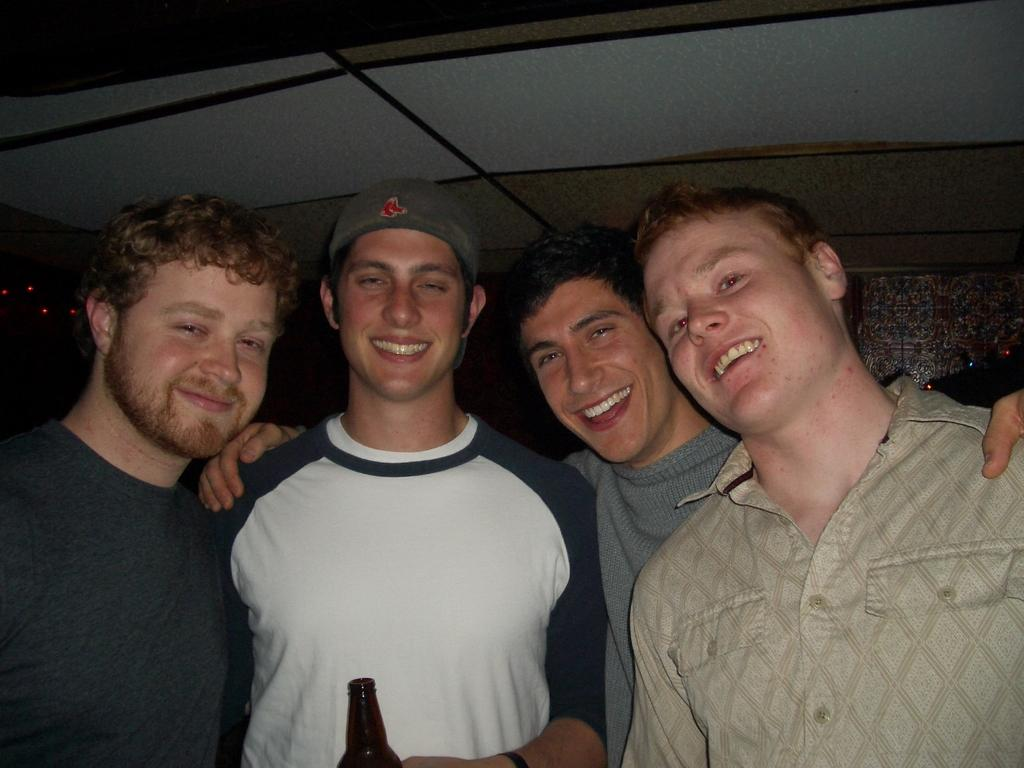What is the main subject of the image? There are people in the center of the image. What can be seen in the background of the image? There is a wall in the background of the image. What is above the people in the image? There is a ceiling at the top of the image. What type of peace offering is being made by the people in the image? There is no indication of a peace offering or any conflict in the image; it simply shows people in the center. 